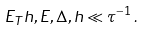<formula> <loc_0><loc_0><loc_500><loc_500>E _ { T } h , E , \Delta , h \ll \tau ^ { - 1 } \, .</formula> 